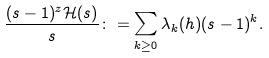<formula> <loc_0><loc_0><loc_500><loc_500>\frac { ( s - 1 ) ^ { z } \mathcal { H } ( s ) } { s } \colon = \sum _ { k \geq 0 } \lambda _ { k } ( h ) ( s - 1 ) ^ { k } .</formula> 